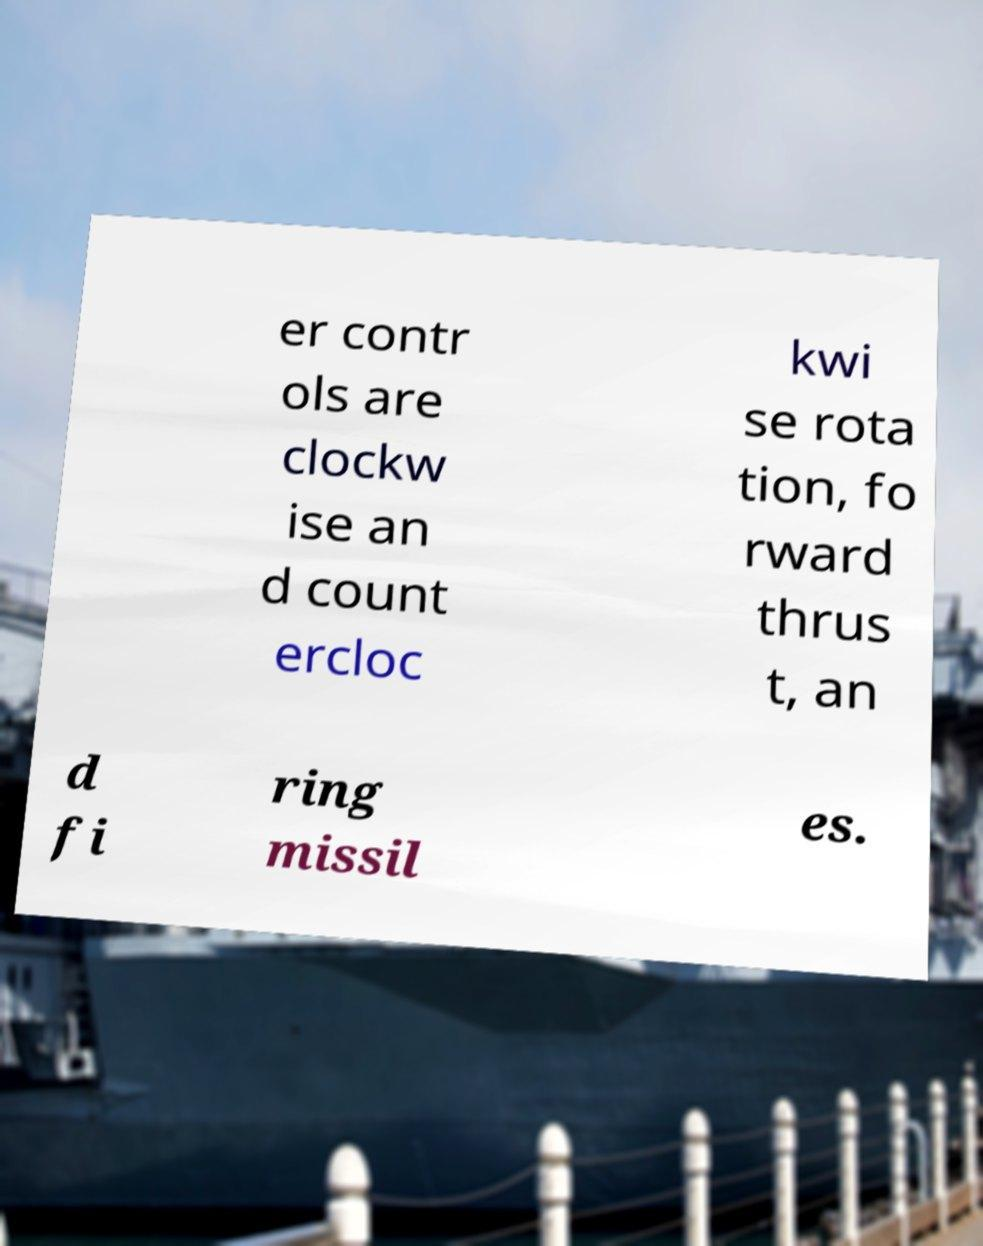What messages or text are displayed in this image? I need them in a readable, typed format. er contr ols are clockw ise an d count ercloc kwi se rota tion, fo rward thrus t, an d fi ring missil es. 